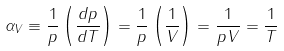<formula> <loc_0><loc_0><loc_500><loc_500>\alpha _ { V } \equiv \frac { 1 } { p } \left ( { \frac { d p } { d T } } \right ) = { \frac { 1 } { p } } \left ( { \frac { 1 } { V } } \right ) = { \frac { 1 } { p V } } = { \frac { 1 } { T } }</formula> 